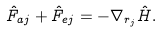<formula> <loc_0><loc_0><loc_500><loc_500>\hat { F } _ { a j } + \hat { F } _ { e j } = - \nabla _ { r _ { j } } \hat { H } .</formula> 